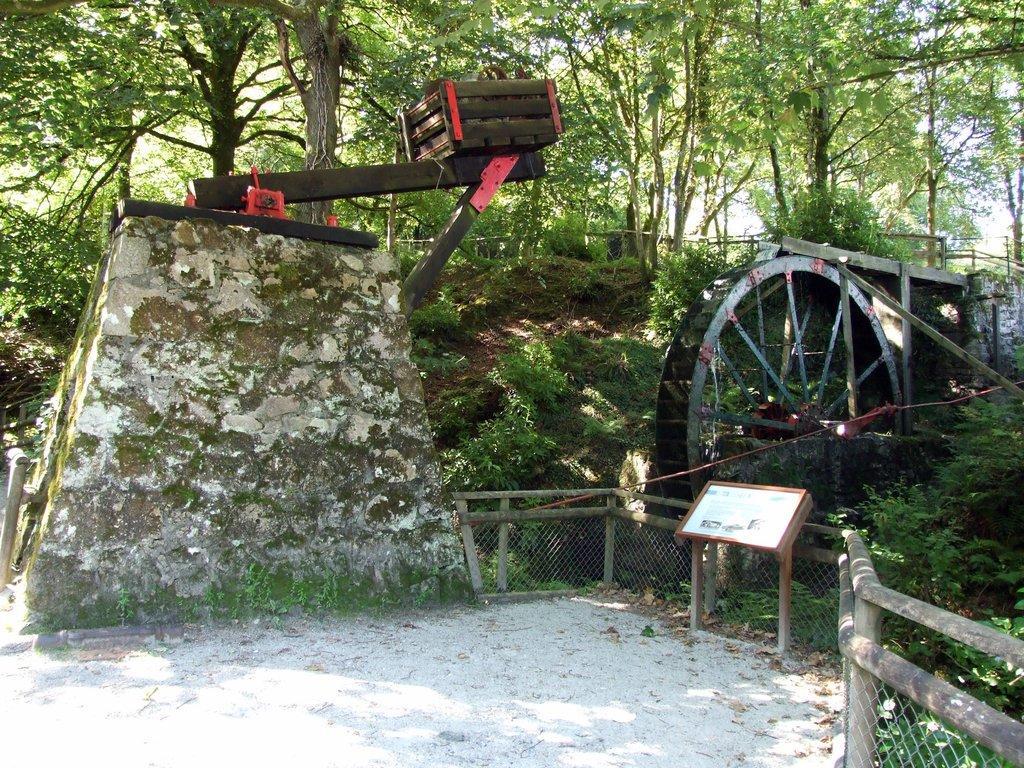Please provide a concise description of this image. In this image, we can see a fence, there is a wooden box and a wall, we can see the wheel, we can see a wooden board, there are some plants and trees. 